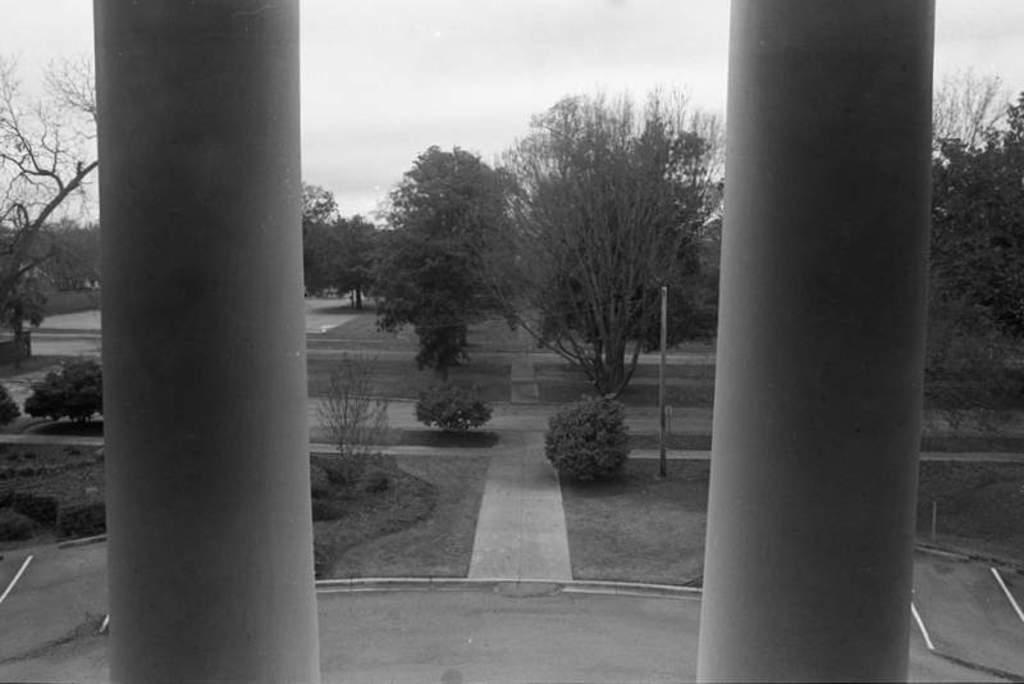How would you summarize this image in a sentence or two? In this picture there are grassland and trees in the center of the image and there are two pillars on the right and left side of the image. 